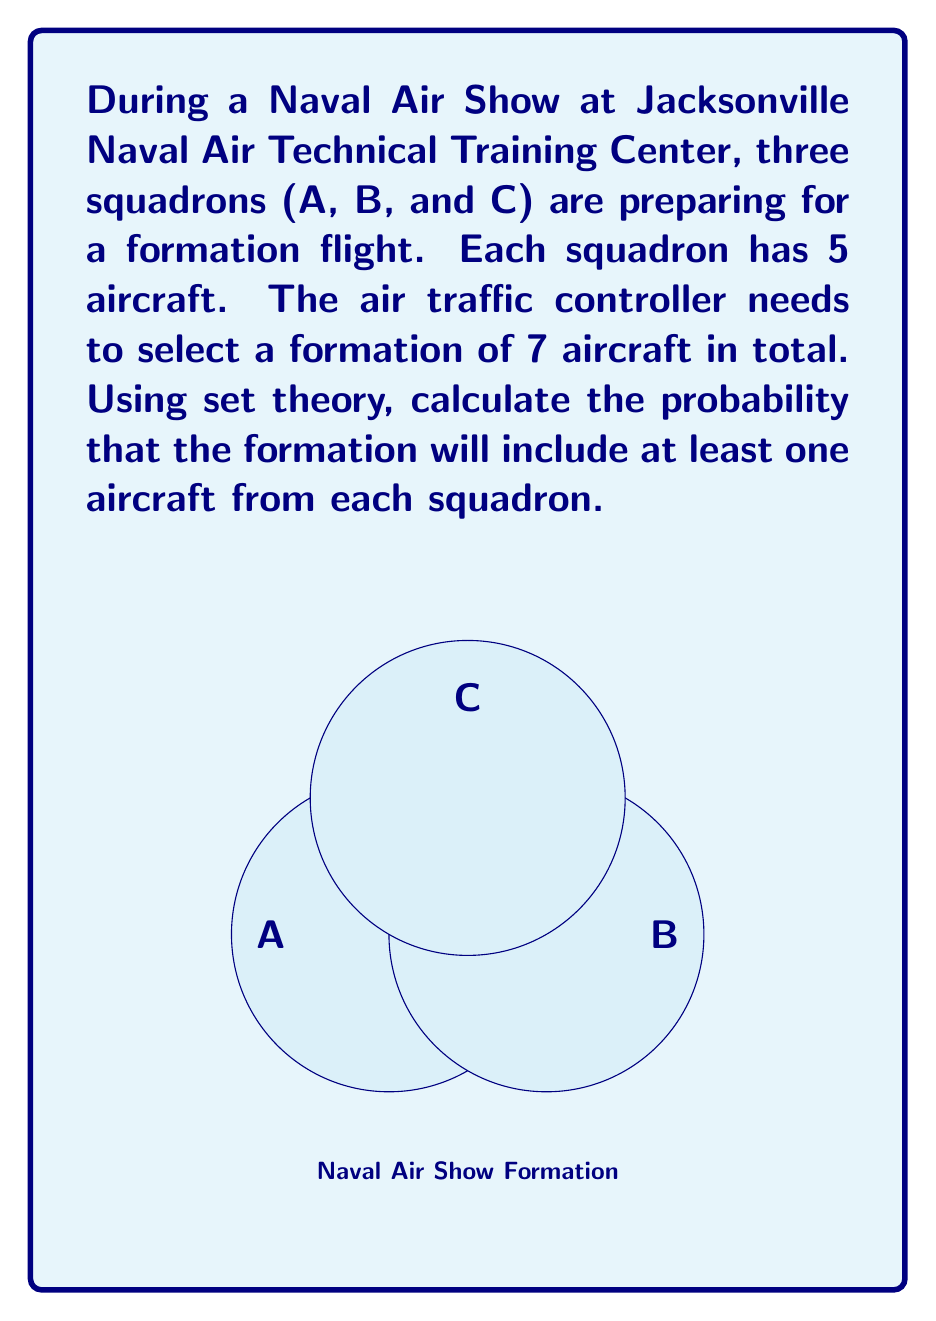Teach me how to tackle this problem. Let's approach this step-by-step using set theory and probability:

1) First, we need to calculate the total number of ways to select 7 aircraft out of 15. This is given by the combination formula:

   $$\binom{15}{7} = \frac{15!}{7!(15-7)!} = 6435$$

2) Now, we need to find the number of favorable outcomes (formations with at least one aircraft from each squadron). It's easier to subtract the unfavorable outcomes from the total:

3) Unfavorable outcomes are those where at least one squadron is not represented. We can calculate this using the Inclusion-Exclusion Principle:

   Let A, B, C be the events of not including any aircraft from squadrons A, B, C respectively.

4) $$|A \cup B \cup C| = |A| + |B| + |C| - |A \cap B| - |B \cap C| - |A \cap C| + |A \cap B \cap C|$$

5) Calculating each term:
   - $|A| = \binom{10}{7} = 120$ (selecting 7 from the other two squadrons)
   - $|B| = |C| = 120$ (same as A)
   - $|A \cap B| = \binom{5}{7} = 0$ (impossible to select 7 from one squadron)
   - $|B \cap C| = |A \cap C| = |A \cap B \cap C| = 0$ (same reason as above)

6) Therefore, $|A \cup B \cup C| = 120 + 120 + 120 = 360$

7) The number of favorable outcomes is thus:
   $$6435 - 360 = 6075$$

8) The probability is therefore:
   $$P(\text{at least one from each}) = \frac{6075}{6435} = \frac{405}{429} \approx 0.9439$$
Answer: $\frac{405}{429}$ 